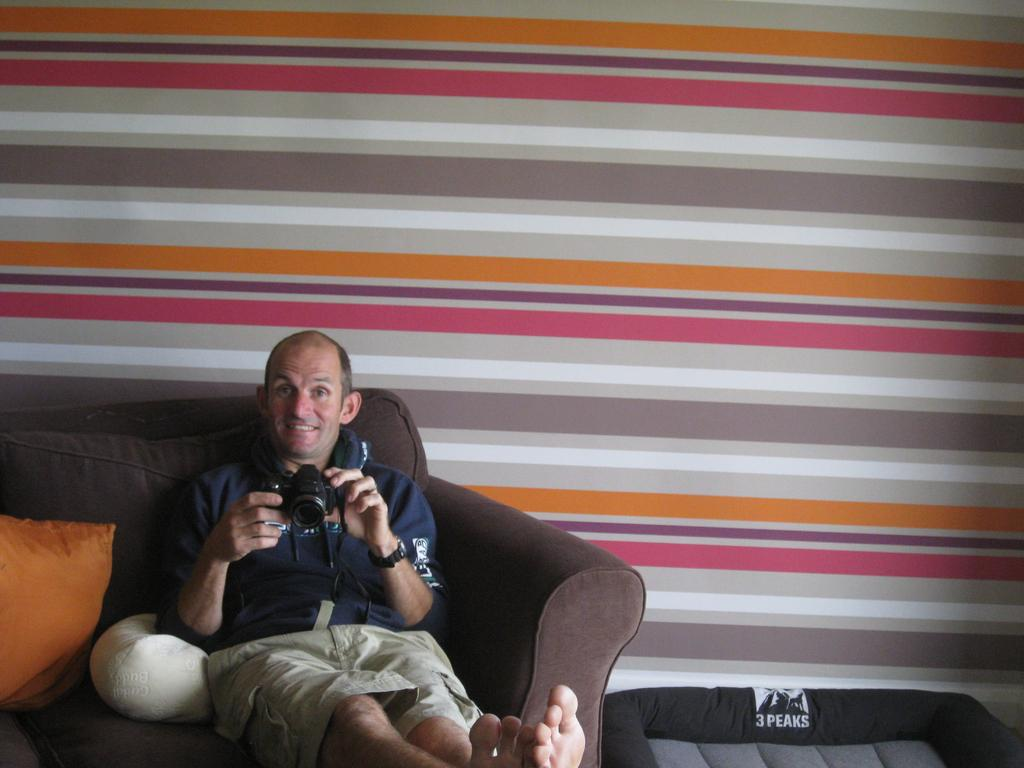What is the person in the image doing? The person is sitting on the sofa. What is the person holding in the image? The person is holding a camera. What colors and types of pillows are on the sofa? There are gold and white color pillows on the sofa. How many rabbits are sitting on the person's lap in the image? There are no rabbits present in the image. What type of insect can be seen crawling on the camera in the image? There are no insects visible on the camera in the image. 